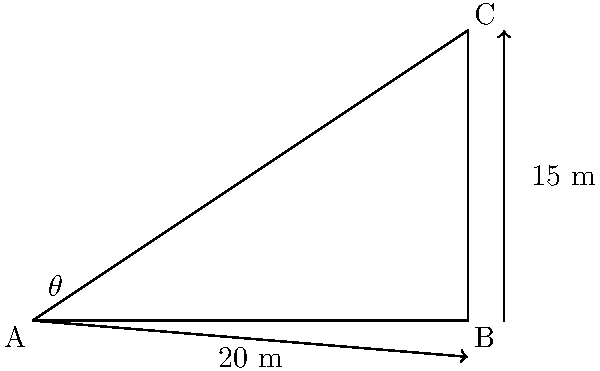As a behavior analyst observing a classroom, you notice a student struggling with a trigonometry problem. The problem involves a 20-meter long ramp leading up to a 15-meter tall building. What is the angle of elevation ($\theta$) of the ramp? Let's approach this step-by-step:

1) First, we identify that we have a right triangle, where:
   - The base (adjacent side) is 20 meters
   - The height (opposite side) is 15 meters
   - We need to find the angle $\theta$

2) To find the angle of elevation, we need to use the arctangent function (inverse tangent or $\tan^{-1}$).

3) The tangent of an angle in a right triangle is the ratio of the opposite side to the adjacent side:

   $\tan(\theta) = \frac{\text{opposite}}{\text{adjacent}} = \frac{15}{20}$

4) To find $\theta$, we take the arctangent of both sides:

   $\theta = \tan^{-1}(\frac{15}{20})$

5) Simplify the fraction:
   
   $\theta = \tan^{-1}(0.75)$

6) Using a calculator or trigonometric tables:

   $\theta \approx 36.87°$

This problem demonstrates how trigonometry can be applied to real-world situations, which could be an interesting point to discuss with the class in terms of practical applications of math.
Answer: $36.87°$ 